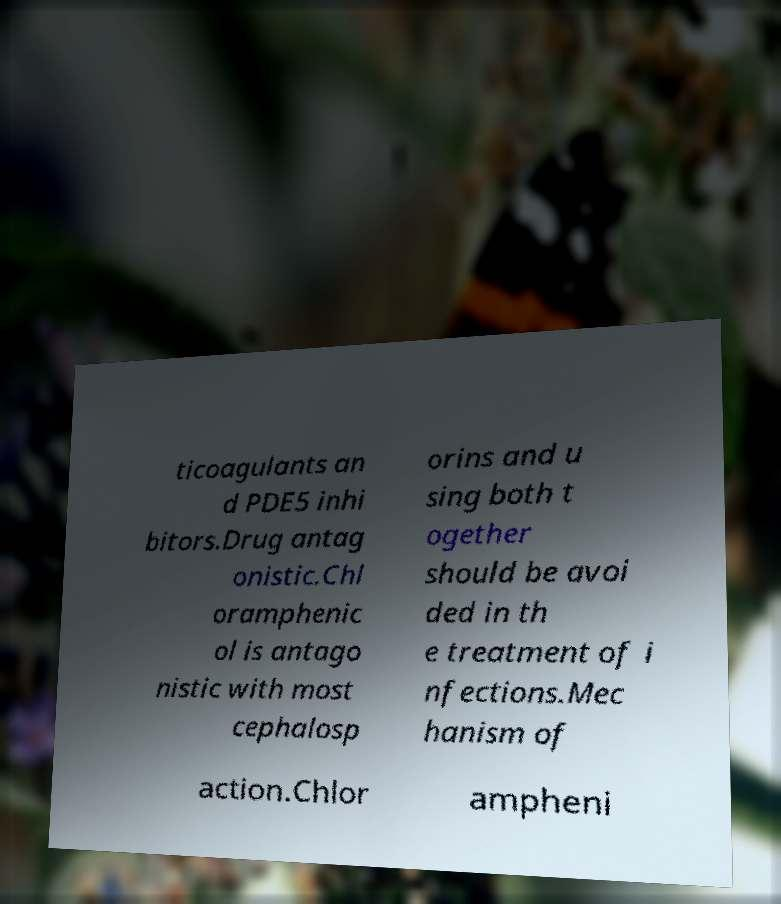Please identify and transcribe the text found in this image. ticoagulants an d PDE5 inhi bitors.Drug antag onistic.Chl oramphenic ol is antago nistic with most cephalosp orins and u sing both t ogether should be avoi ded in th e treatment of i nfections.Mec hanism of action.Chlor ampheni 